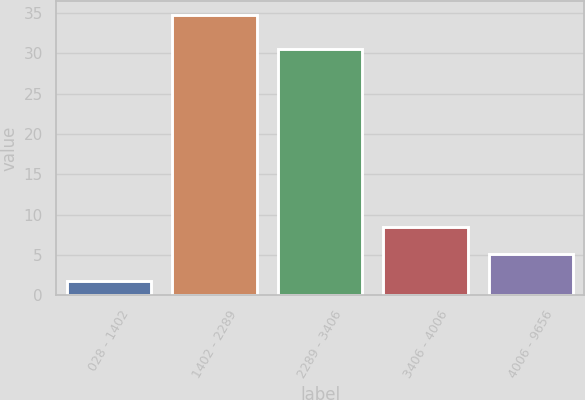Convert chart to OTSL. <chart><loc_0><loc_0><loc_500><loc_500><bar_chart><fcel>028 - 1402<fcel>1402 - 2289<fcel>2289 - 3406<fcel>3406 - 4006<fcel>4006 - 9656<nl><fcel>1.8<fcel>34.7<fcel>30.5<fcel>8.5<fcel>5.09<nl></chart> 